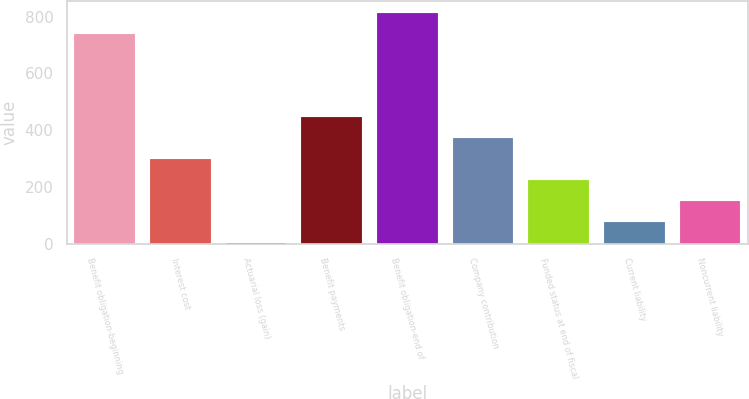<chart> <loc_0><loc_0><loc_500><loc_500><bar_chart><fcel>Benefit obligation-beginning<fcel>Interest cost<fcel>Actuarial loss (gain)<fcel>Benefit payments<fcel>Benefit obligation-end of<fcel>Company contribution<fcel>Funded status at end of fiscal<fcel>Current liability<fcel>Noncurrent liability<nl><fcel>739<fcel>299<fcel>3<fcel>447<fcel>813<fcel>373<fcel>225<fcel>77<fcel>151<nl></chart> 